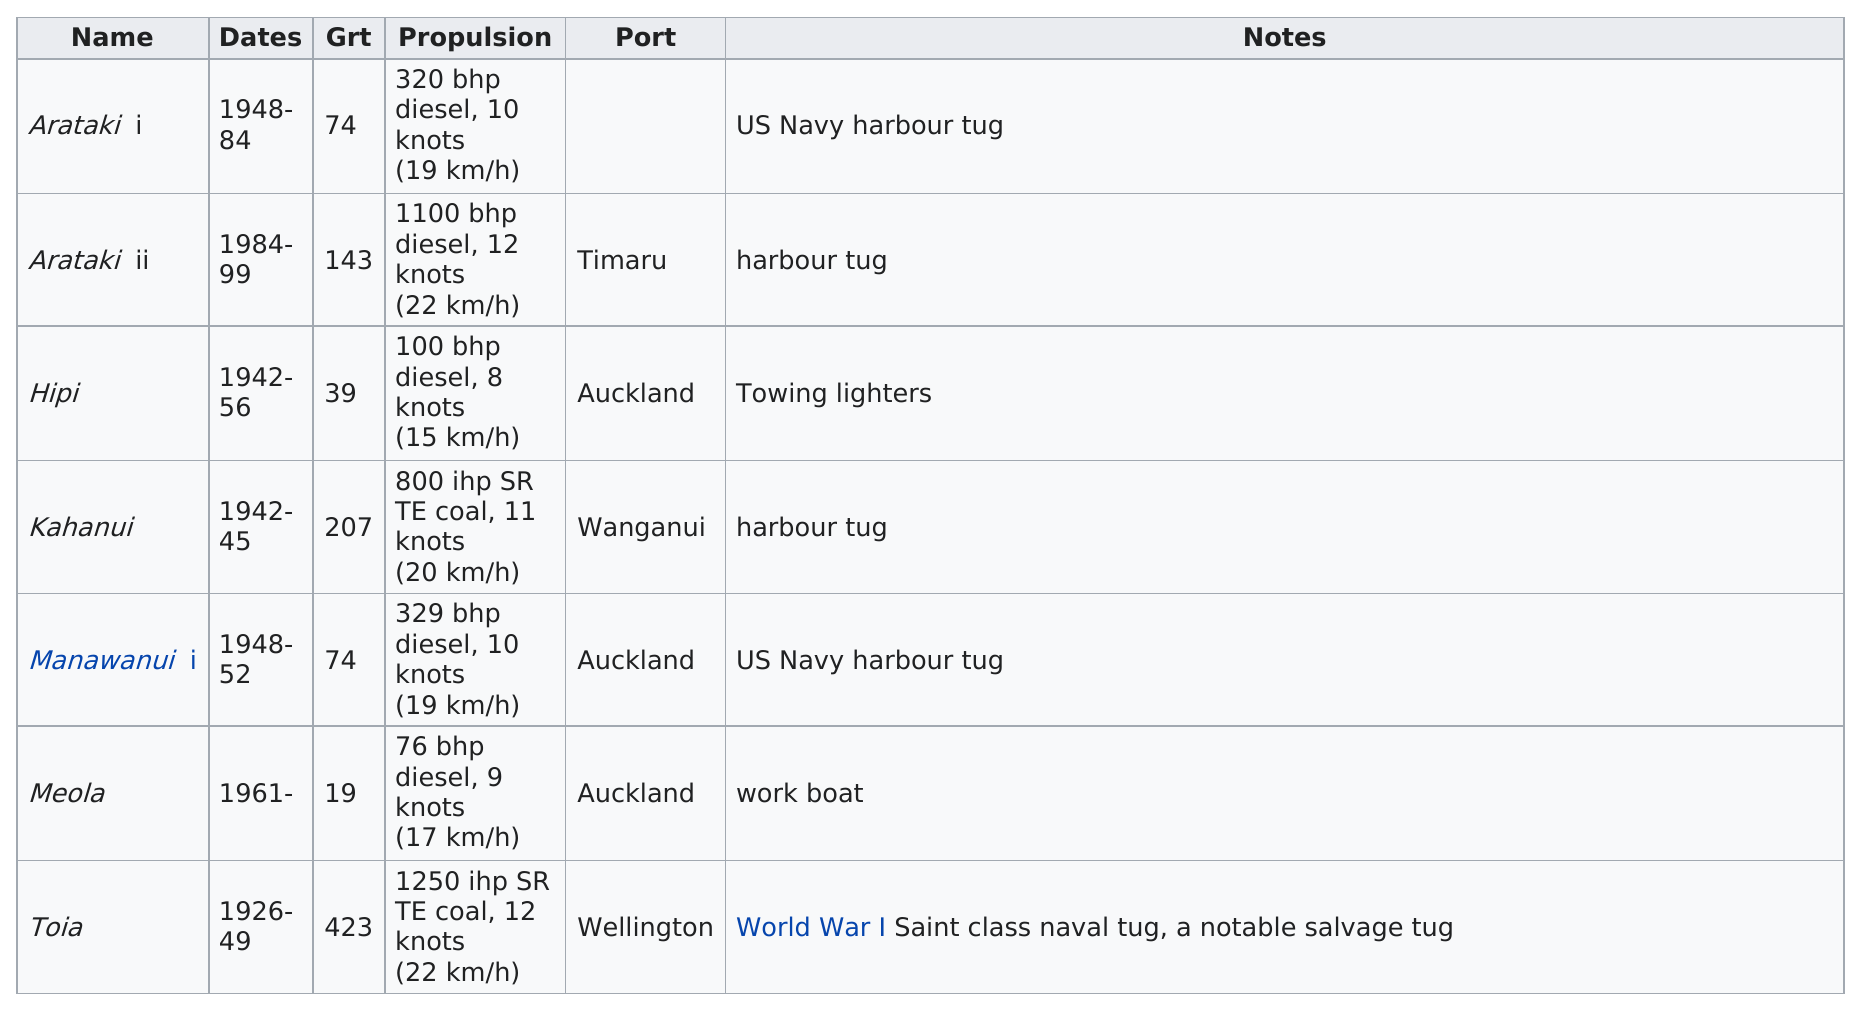List a handful of essential elements in this visual. The Meola is the only ship that has been used exclusively as a workboat. The Manawanui was the ship in Auckland with the fastest speed in knots. The vessels with propulsion speed under 10 knots include Hipi and Meola. Four ships at the port of Auckland reached the end of their service dates before the MEOLA started service in 1961. 